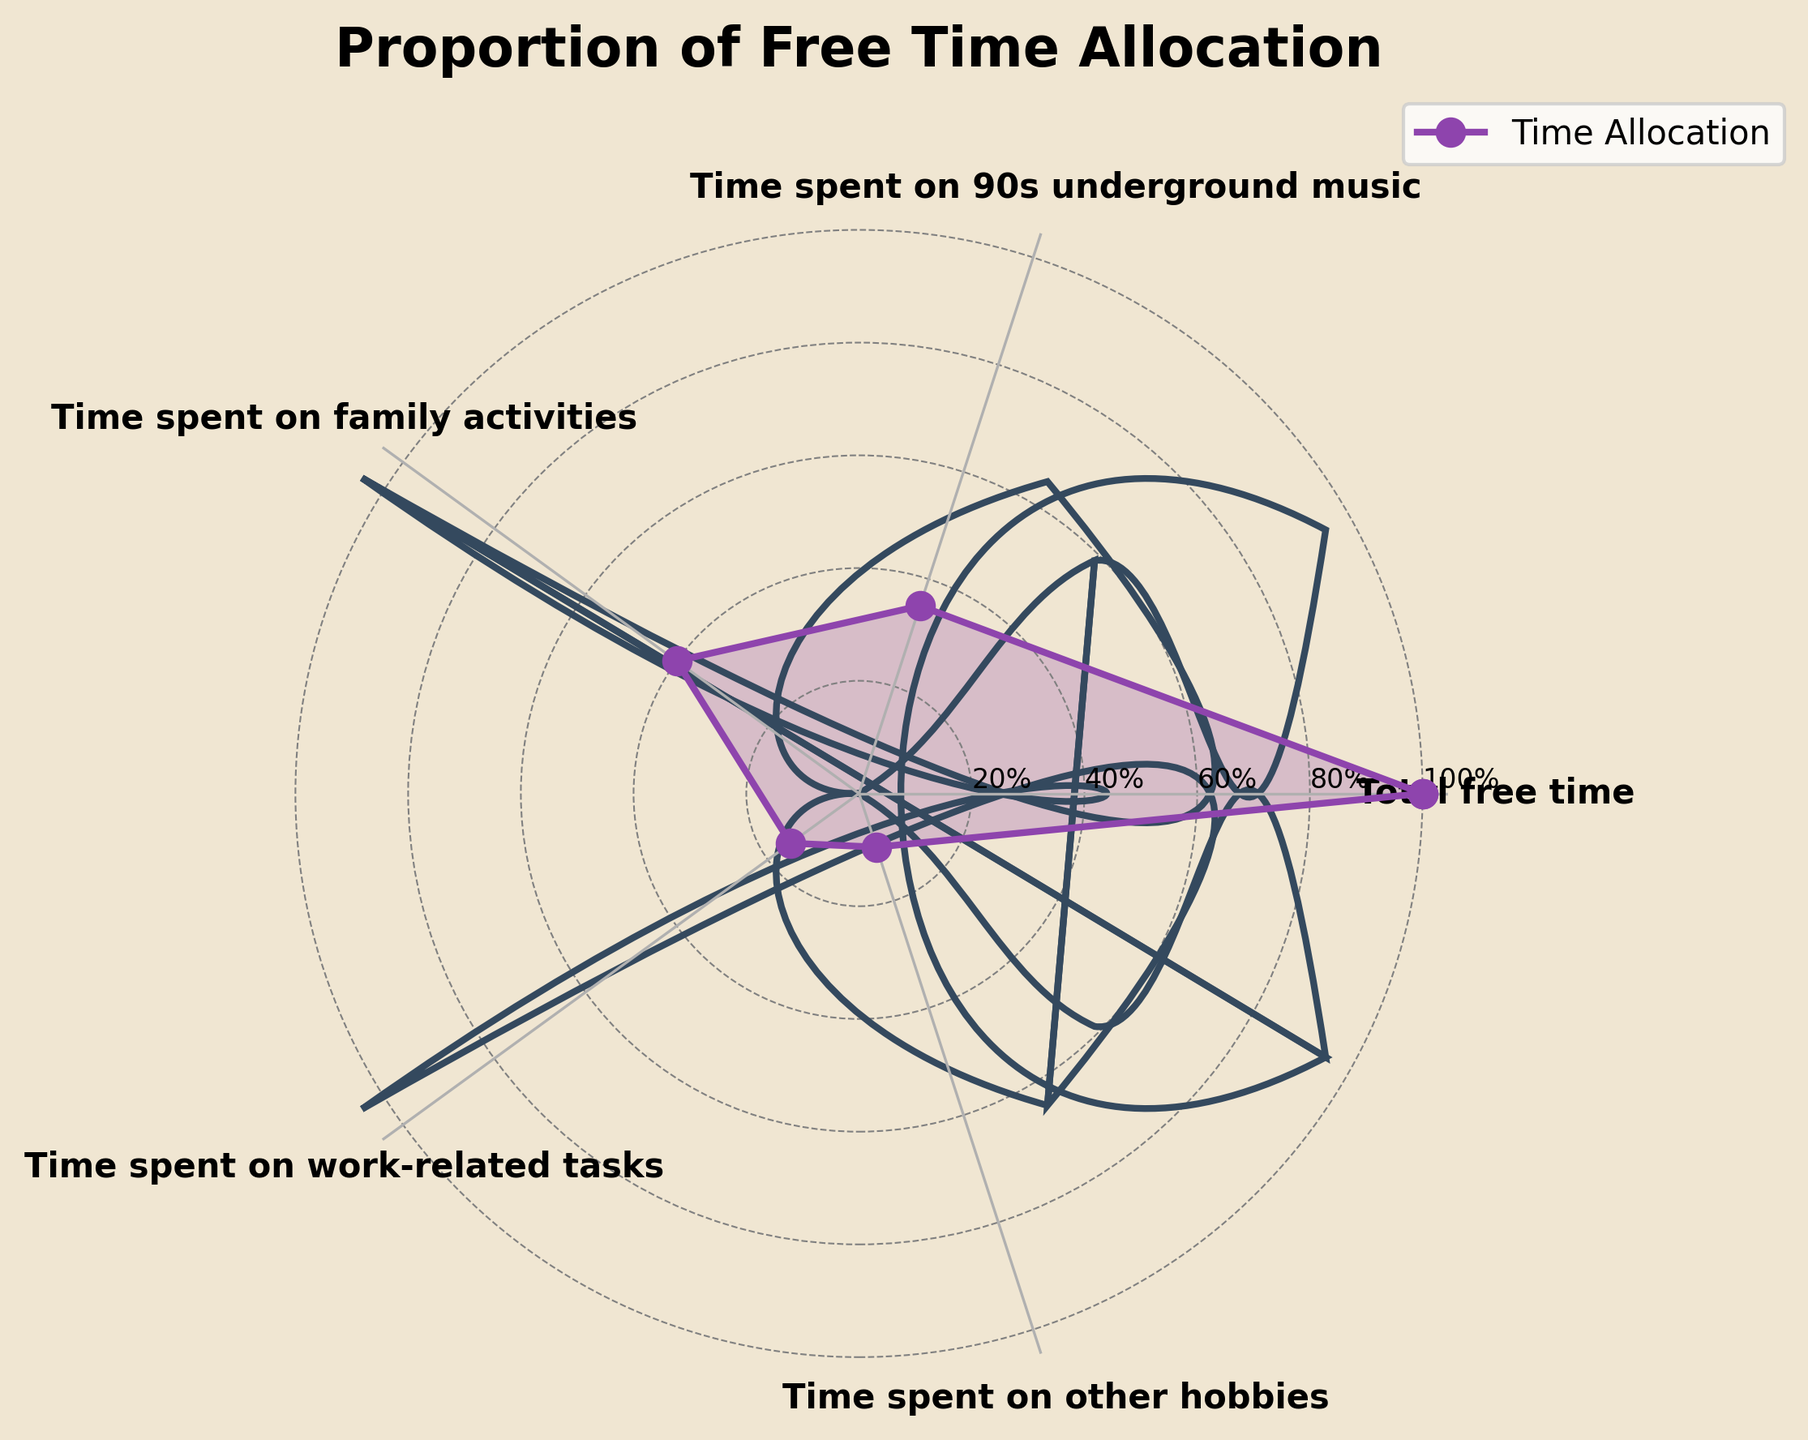What is the title of the plot? The title is clearly shown at the top of the figure, indicating what the data represents.
Answer: Proportion of Free Time Allocation How much free time is spent on rediscovering 90s underground music? The plot displays the proportion of free time, and the corresponding label for 90s underground music can be read directly from the plot.
Answer: 35% Which activity takes up the most free time? By comparing the sizes of the segments on the plot, it is clear which category has the largest portion of free time.
Answer: Family activities Is the time spent on rediscovering 90s underground music greater than the time spent on work-related tasks and other hobbies combined? Add the proportions of work-related tasks (15%) and other hobbies (10%), then compare the sum (25%) to the 35% of time spent on 90s underground music.
Answer: Yes How does the time spent on family activities compare to the total free time? The plot displays labels that sum to 100%, allowing for a direct read-off of the proportion allocated to family activities.
Answer: 40% What percentage of free time is spent on activities other than rediscovering 90s underground music? Subtract the percentage of time spent on 90s underground music (35%) from the total free time (100%).
Answer: 65% How does the time spent on work-related tasks compare to the time spent on other hobbies? Compare the proportions for work-related tasks (15%) and other hobbies (10%) directly from the plot.
Answer: Greater What is the smallest proportion of free time spent among the categories listed? Identify the smallest value on the plot from the displayed categories.
Answer: Other hobbies If you wanted to spend the same amount of time on rediscovering 90s underground music and other hobbies, how much more time would need to be allocated to other hobbies? Calculate the difference between the time spent on 90s underground music (35%) and other hobbies (10%).
Answer: 25% Which activity has the closest proportion of free time to 30%? Compare all the proportions shown on the plot to see which one is closest to 30%.
Answer: Rediscovering 90s underground music 